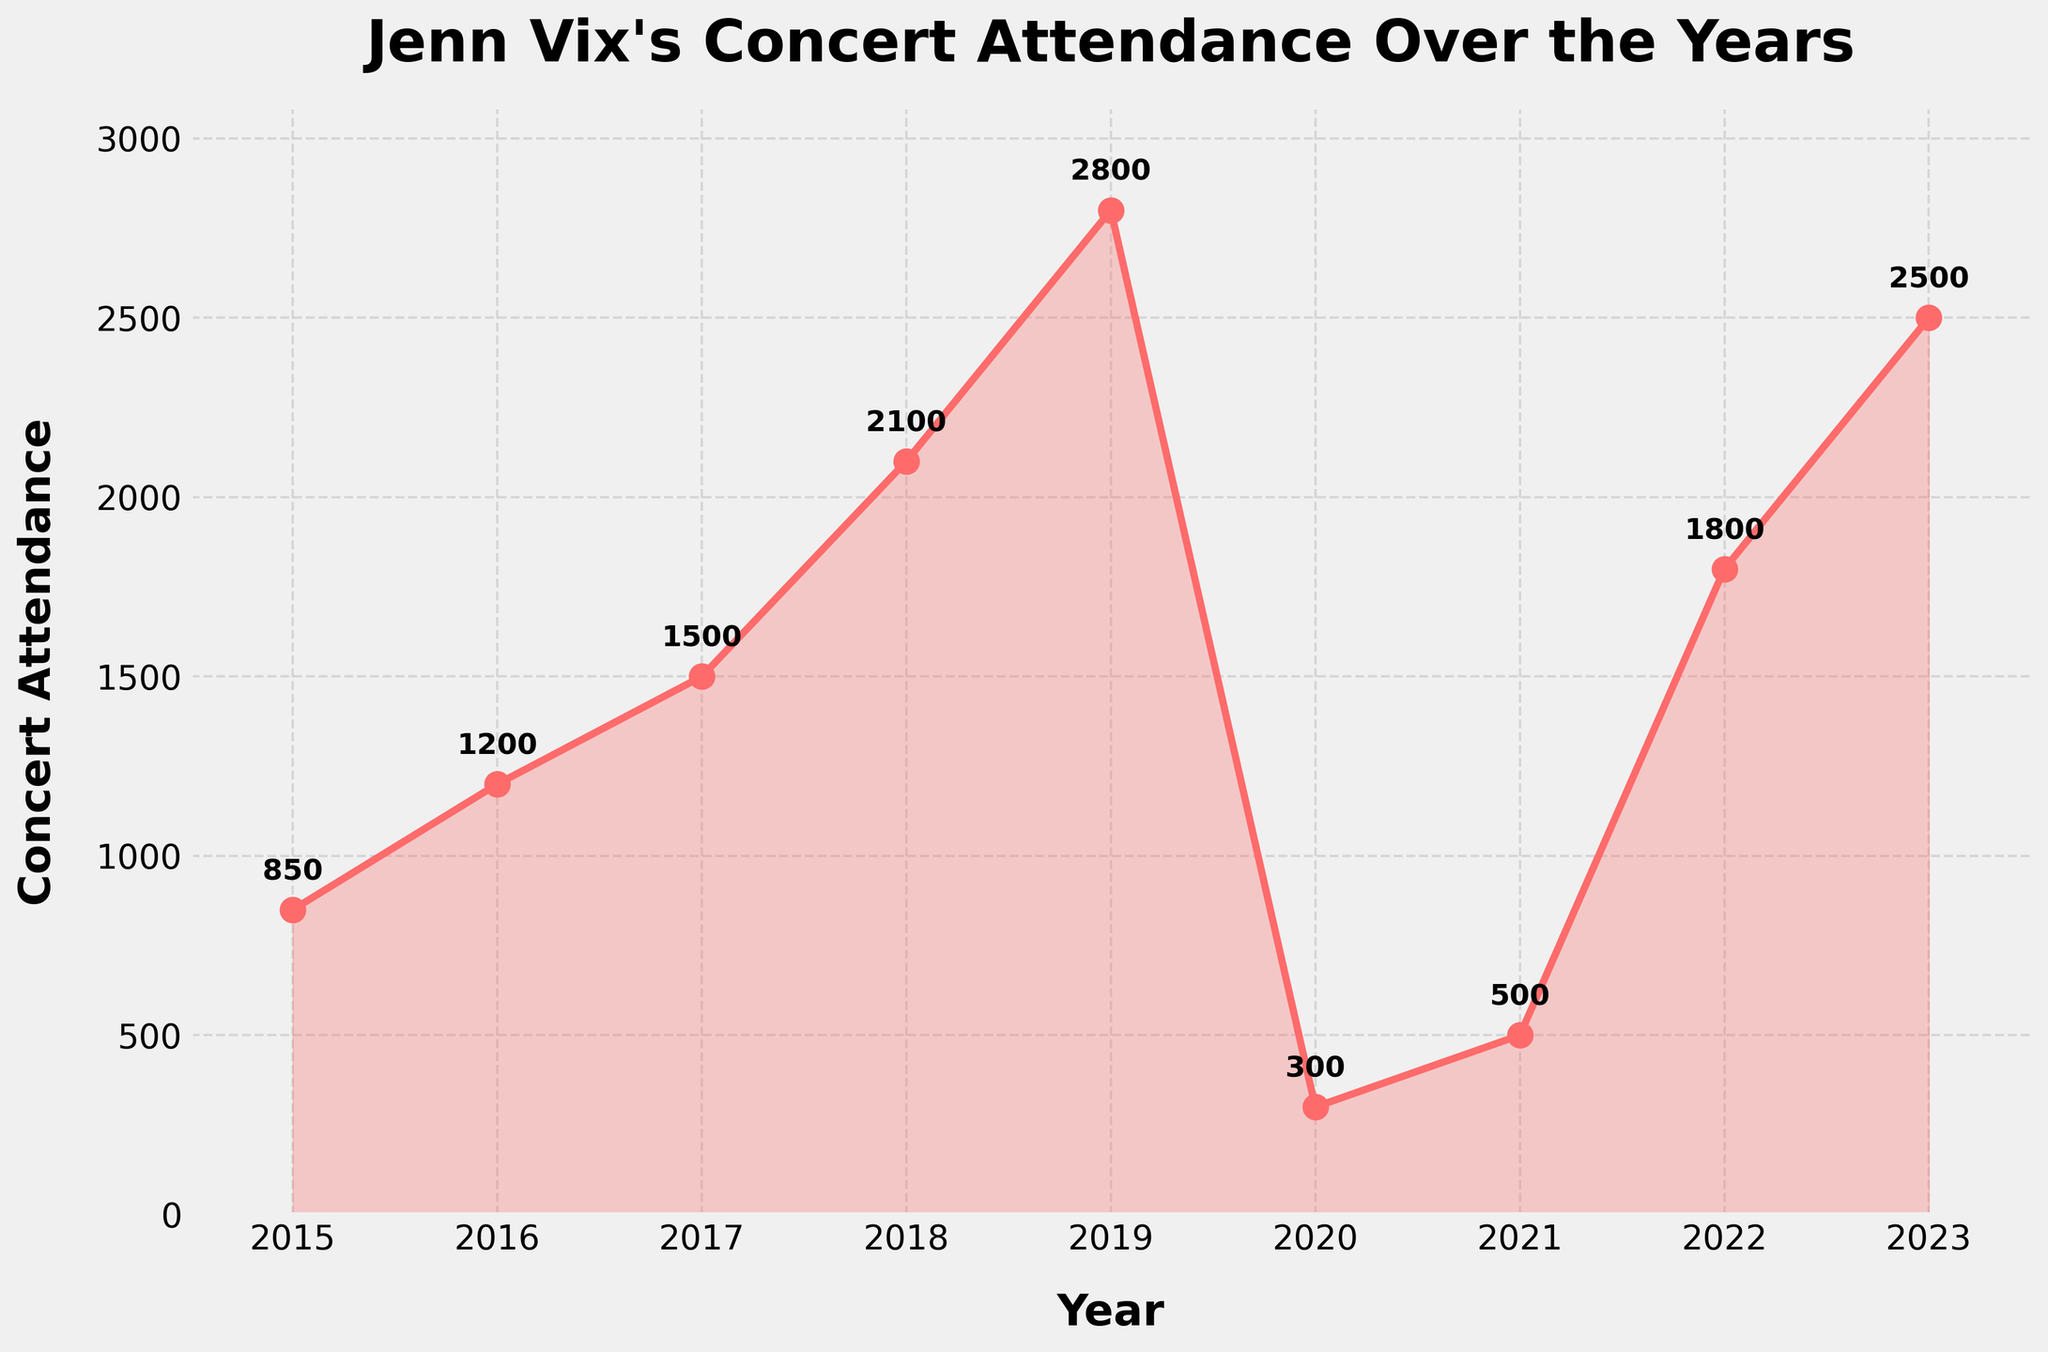What is the highest concert attendance? Find the highest point on the line, which corresponds to the year 2019 with 2800 attendees.
Answer: 2800 Between which two consecutive years did Jenn Vix see the steepest increase in concert attendance? Compare the slope of the line between each consecutive pair of years. The steepest increase is between 2018 (2100) and 2019 (2800), a rise of 700.
Answer: 2018 and 2019 What's the total concert attendance over the given years? Add up the concert attendance values for each year: 850 + 1200 + 1500 + 2100 + 2800 + 300 + 500 + 1800 + 2500 = 13550
Answer: 13550 What was the concert attendance in the year 2020? Find the data point for the year 2020, which shows an attendance of 300.
Answer: 300 How did the concert attendance change from 2019 to 2020, and what might be the reason? From 2019 to 2020, the attendance dropped from 2800 to 300, a difference of 2500. This large drop could be attributed to the COVID-19 pandemic.
Answer: Dropped by 2500, likely due to COVID-19 Which year had the second lowest concert attendance? The lowest attendance is in 2020 with 300 attendees. The next lowest is 2021 with 500 attendees.
Answer: 2021 What is the average concert attendance from 2015 to 2023? Sum the concert attendance for all years and divide by the number of years: (850 + 1200 + 1500 + 2100 + 2800 + 300 + 500 + 1800 + 2500) / 9 = 1505.56
Answer: 1505.56 In which year did Jenn Vix experience a recovery in concert attendance after the steepest decline? After the steep decline between 2019 (2800) and 2020 (300), the first year showing significant recovery is 2021 with 500 attendees, then further recovery in 2022 and 2023.
Answer: 2021 What percentage of the highest attendance in 2019 was the concert attendance in 2023? Calculate the percentage of 2019's attendance that was achieved in 2023. (2500 / 2800) * 100 = 89.29%
Answer: 89.29% How do the concert attendance values in 2016 and 2022 compare? Compare the values for 2016 (1200) and 2022 (1800). 2022's attendance is higher by 600.
Answer: 2022 is higher by 600 